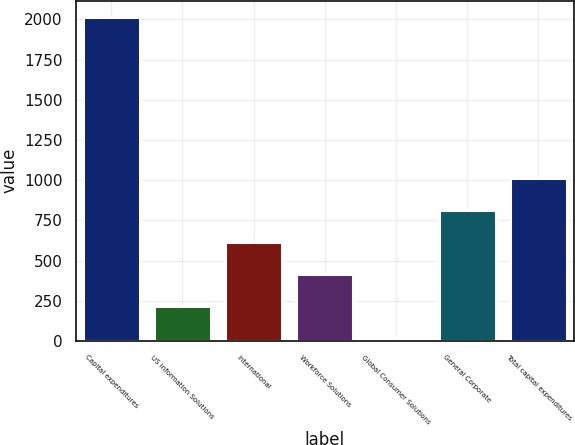<chart> <loc_0><loc_0><loc_500><loc_500><bar_chart><fcel>Capital expenditures<fcel>US Information Solutions<fcel>International<fcel>Workforce Solutions<fcel>Global Consumer Solutions<fcel>General Corporate<fcel>Total capital expenditures<nl><fcel>2017<fcel>215.2<fcel>615.6<fcel>415.4<fcel>15<fcel>815.8<fcel>1016<nl></chart> 